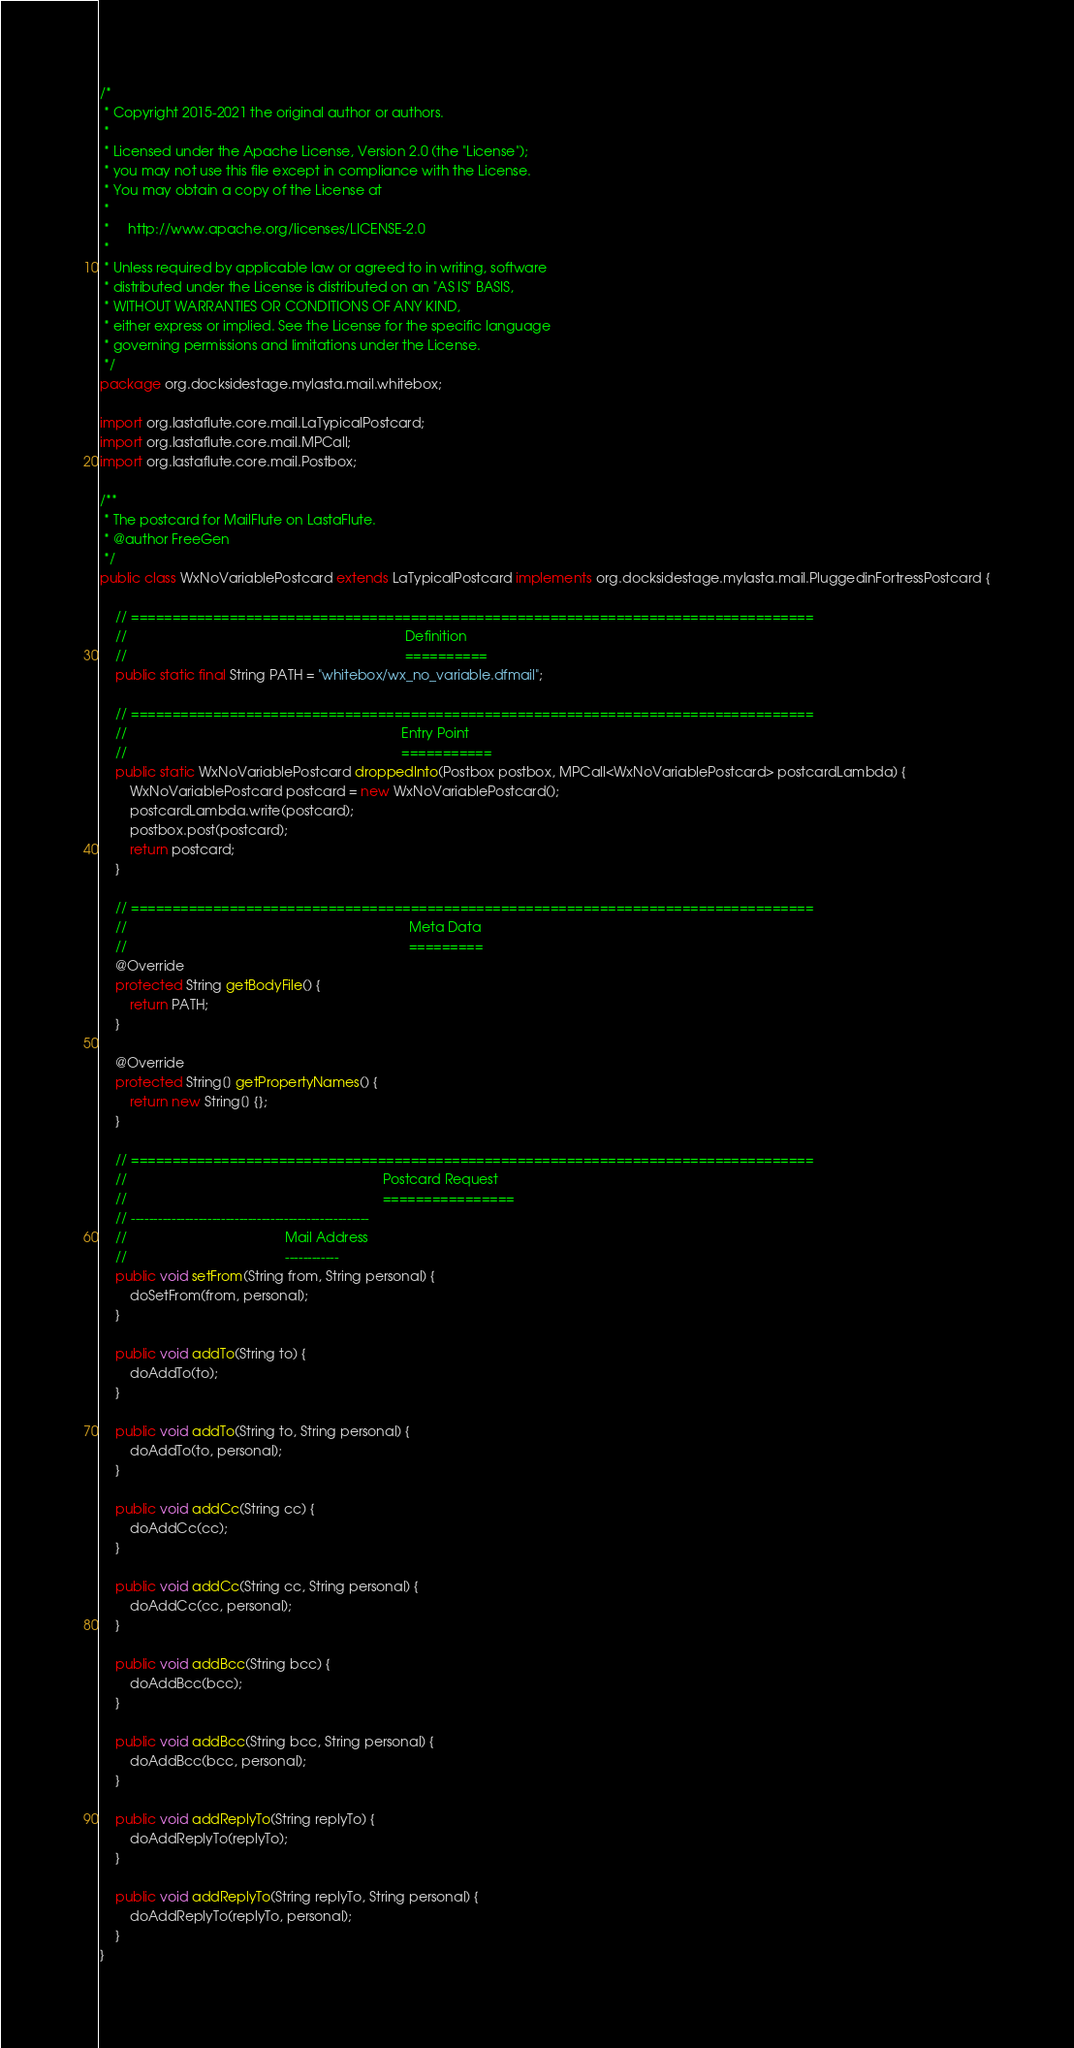Convert code to text. <code><loc_0><loc_0><loc_500><loc_500><_Java_>/*
 * Copyright 2015-2021 the original author or authors.
 *
 * Licensed under the Apache License, Version 2.0 (the "License");
 * you may not use this file except in compliance with the License.
 * You may obtain a copy of the License at
 *
 *     http://www.apache.org/licenses/LICENSE-2.0
 *
 * Unless required by applicable law or agreed to in writing, software
 * distributed under the License is distributed on an "AS IS" BASIS,
 * WITHOUT WARRANTIES OR CONDITIONS OF ANY KIND,
 * either express or implied. See the License for the specific language
 * governing permissions and limitations under the License.
 */
package org.docksidestage.mylasta.mail.whitebox;

import org.lastaflute.core.mail.LaTypicalPostcard;
import org.lastaflute.core.mail.MPCall;
import org.lastaflute.core.mail.Postbox;

/**
 * The postcard for MailFlute on LastaFlute.
 * @author FreeGen
 */
public class WxNoVariablePostcard extends LaTypicalPostcard implements org.docksidestage.mylasta.mail.PluggedinFortressPostcard {

    // ===================================================================================
    //                                                                          Definition
    //                                                                          ==========
    public static final String PATH = "whitebox/wx_no_variable.dfmail";

    // ===================================================================================
    //                                                                         Entry Point
    //                                                                         ===========
    public static WxNoVariablePostcard droppedInto(Postbox postbox, MPCall<WxNoVariablePostcard> postcardLambda) {
        WxNoVariablePostcard postcard = new WxNoVariablePostcard();
        postcardLambda.write(postcard);
        postbox.post(postcard);
        return postcard;
    }

    // ===================================================================================
    //                                                                           Meta Data
    //                                                                           =========
    @Override
    protected String getBodyFile() {
        return PATH;
    }

    @Override
    protected String[] getPropertyNames() {
        return new String[] {};
    }

    // ===================================================================================
    //                                                                    Postcard Request
    //                                                                    ================
    // -----------------------------------------------------
    //                                          Mail Address
    //                                          ------------
    public void setFrom(String from, String personal) {
        doSetFrom(from, personal);
    }

    public void addTo(String to) {
        doAddTo(to);
    }

    public void addTo(String to, String personal) {
        doAddTo(to, personal);
    }

    public void addCc(String cc) {
        doAddCc(cc);
    }

    public void addCc(String cc, String personal) {
        doAddCc(cc, personal);
    }

    public void addBcc(String bcc) {
        doAddBcc(bcc);
    }

    public void addBcc(String bcc, String personal) {
        doAddBcc(bcc, personal);
    }

    public void addReplyTo(String replyTo) {
        doAddReplyTo(replyTo);
    }

    public void addReplyTo(String replyTo, String personal) {
        doAddReplyTo(replyTo, personal);
    }
}
</code> 